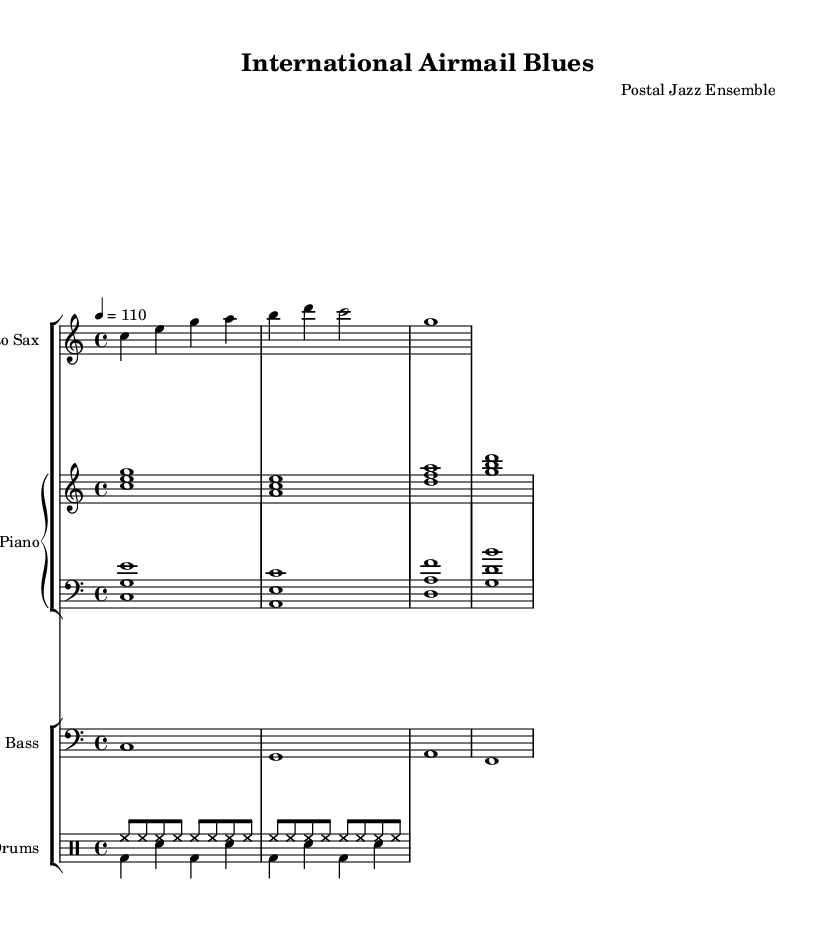What is the key signature of this music? The key signature is C major, which has no sharps or flats.
Answer: C major What is the time signature of this piece? The time signature is indicated in the beginning and shows a measure of four beats per bar.
Answer: 4/4 What is the tempo marking shown in the music? The tempo marking is indicated as quarter note equals 110, which sets the speed of the piece.
Answer: 110 How many measures are there in the saxophone part? By counting the number of vertical bar lines, we see that there are four measures in the saxophone part.
Answer: 4 What dynamic level might you expect for a piece labeled "International Airmail Blues"? Considering the title and genre, it is reasonable to expect a relaxed or laid-back dynamic typically associated with cool jazz interpretations.
Answer: Relaxed Which instruments are included in this arrangement? The arrangement clearly shows the parts for alto sax, piano, bass, and drums, indicating the instrumentation for the group.
Answer: Alto Sax, Piano, Bass, Drums In what style is this composition likely performed? The title "International Airmail Blues" suggests a jazz style, particularly cool jazz, given its relaxed tempo and instrumentation.
Answer: Cool Jazz 